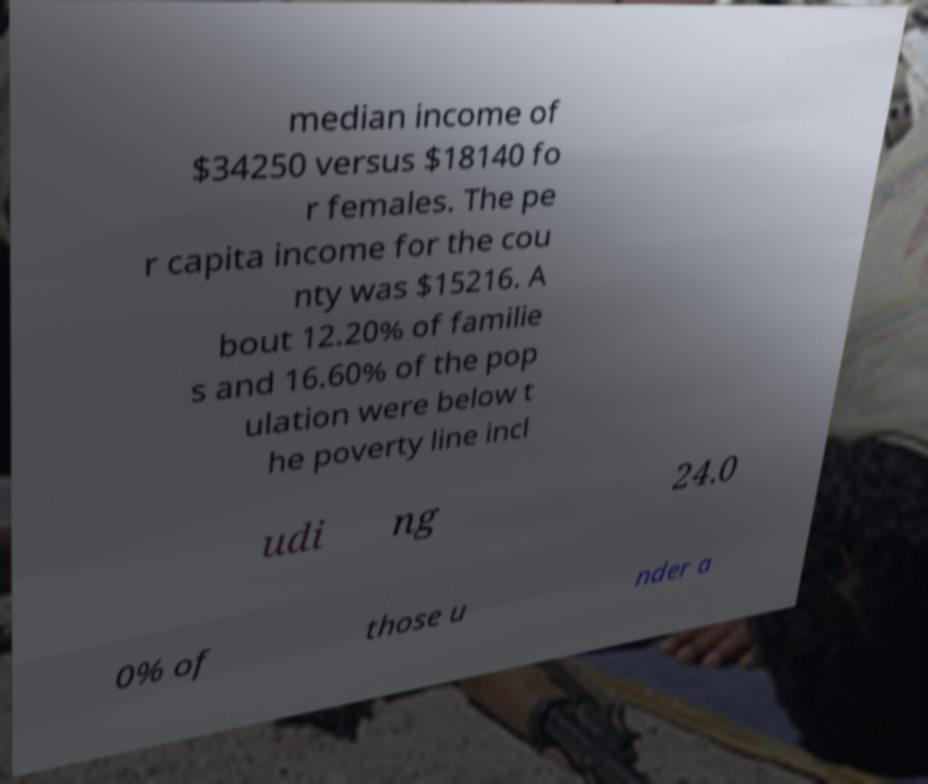Can you read and provide the text displayed in the image?This photo seems to have some interesting text. Can you extract and type it out for me? median income of $34250 versus $18140 fo r females. The pe r capita income for the cou nty was $15216. A bout 12.20% of familie s and 16.60% of the pop ulation were below t he poverty line incl udi ng 24.0 0% of those u nder a 